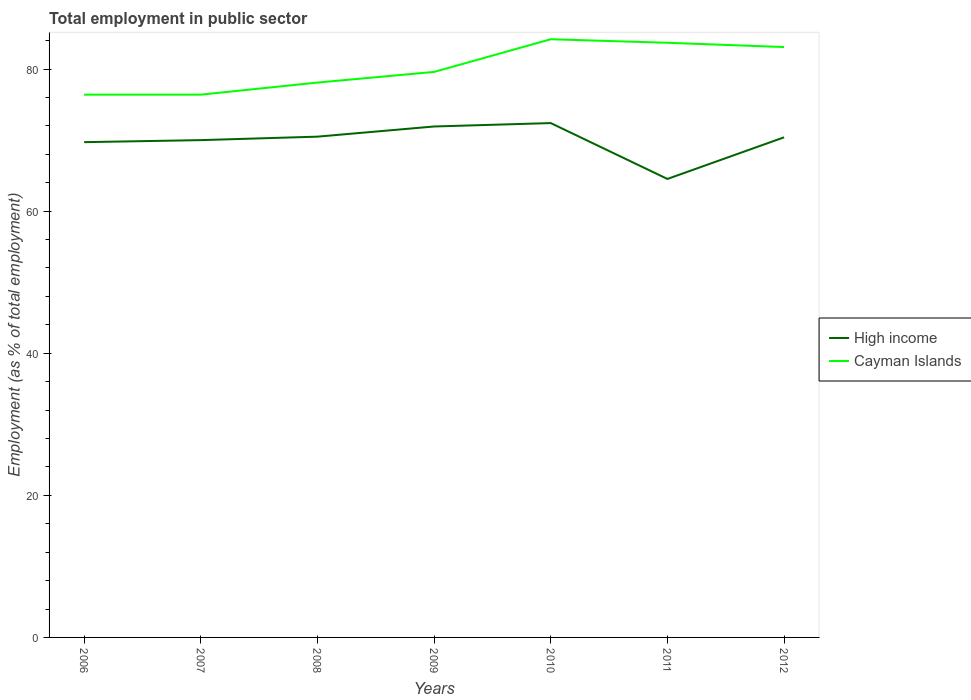Does the line corresponding to Cayman Islands intersect with the line corresponding to High income?
Offer a terse response. No. Across all years, what is the maximum employment in public sector in Cayman Islands?
Offer a terse response. 76.4. What is the total employment in public sector in High income in the graph?
Ensure brevity in your answer.  -0.4. What is the difference between the highest and the second highest employment in public sector in High income?
Provide a short and direct response. 7.86. What is the difference between the highest and the lowest employment in public sector in High income?
Your answer should be compact. 5. Is the employment in public sector in Cayman Islands strictly greater than the employment in public sector in High income over the years?
Ensure brevity in your answer.  No. How many lines are there?
Keep it short and to the point. 2. How many years are there in the graph?
Your answer should be compact. 7. Does the graph contain any zero values?
Offer a very short reply. No. Does the graph contain grids?
Your answer should be compact. No. Where does the legend appear in the graph?
Ensure brevity in your answer.  Center right. How many legend labels are there?
Your response must be concise. 2. What is the title of the graph?
Give a very brief answer. Total employment in public sector. Does "Liechtenstein" appear as one of the legend labels in the graph?
Your answer should be very brief. No. What is the label or title of the X-axis?
Provide a succinct answer. Years. What is the label or title of the Y-axis?
Your response must be concise. Employment (as % of total employment). What is the Employment (as % of total employment) of High income in 2006?
Your answer should be very brief. 69.71. What is the Employment (as % of total employment) in Cayman Islands in 2006?
Make the answer very short. 76.4. What is the Employment (as % of total employment) in High income in 2007?
Provide a short and direct response. 70. What is the Employment (as % of total employment) of Cayman Islands in 2007?
Your answer should be compact. 76.4. What is the Employment (as % of total employment) of High income in 2008?
Offer a terse response. 70.49. What is the Employment (as % of total employment) in Cayman Islands in 2008?
Offer a terse response. 78.1. What is the Employment (as % of total employment) of High income in 2009?
Ensure brevity in your answer.  71.92. What is the Employment (as % of total employment) of Cayman Islands in 2009?
Your response must be concise. 79.6. What is the Employment (as % of total employment) of High income in 2010?
Your answer should be compact. 72.4. What is the Employment (as % of total employment) of Cayman Islands in 2010?
Give a very brief answer. 84.2. What is the Employment (as % of total employment) of High income in 2011?
Offer a very short reply. 64.53. What is the Employment (as % of total employment) of Cayman Islands in 2011?
Keep it short and to the point. 83.7. What is the Employment (as % of total employment) in High income in 2012?
Give a very brief answer. 70.4. What is the Employment (as % of total employment) of Cayman Islands in 2012?
Your answer should be very brief. 83.1. Across all years, what is the maximum Employment (as % of total employment) of High income?
Make the answer very short. 72.4. Across all years, what is the maximum Employment (as % of total employment) of Cayman Islands?
Provide a succinct answer. 84.2. Across all years, what is the minimum Employment (as % of total employment) of High income?
Provide a succinct answer. 64.53. Across all years, what is the minimum Employment (as % of total employment) of Cayman Islands?
Keep it short and to the point. 76.4. What is the total Employment (as % of total employment) in High income in the graph?
Your answer should be compact. 489.45. What is the total Employment (as % of total employment) in Cayman Islands in the graph?
Your answer should be very brief. 561.5. What is the difference between the Employment (as % of total employment) of High income in 2006 and that in 2007?
Offer a terse response. -0.28. What is the difference between the Employment (as % of total employment) in High income in 2006 and that in 2008?
Ensure brevity in your answer.  -0.77. What is the difference between the Employment (as % of total employment) in Cayman Islands in 2006 and that in 2008?
Your answer should be compact. -1.7. What is the difference between the Employment (as % of total employment) of High income in 2006 and that in 2009?
Your answer should be very brief. -2.21. What is the difference between the Employment (as % of total employment) in High income in 2006 and that in 2010?
Offer a terse response. -2.68. What is the difference between the Employment (as % of total employment) in Cayman Islands in 2006 and that in 2010?
Your answer should be very brief. -7.8. What is the difference between the Employment (as % of total employment) of High income in 2006 and that in 2011?
Give a very brief answer. 5.18. What is the difference between the Employment (as % of total employment) in Cayman Islands in 2006 and that in 2011?
Offer a very short reply. -7.3. What is the difference between the Employment (as % of total employment) in High income in 2006 and that in 2012?
Provide a short and direct response. -0.68. What is the difference between the Employment (as % of total employment) of Cayman Islands in 2006 and that in 2012?
Offer a terse response. -6.7. What is the difference between the Employment (as % of total employment) in High income in 2007 and that in 2008?
Ensure brevity in your answer.  -0.49. What is the difference between the Employment (as % of total employment) of Cayman Islands in 2007 and that in 2008?
Provide a succinct answer. -1.7. What is the difference between the Employment (as % of total employment) of High income in 2007 and that in 2009?
Your response must be concise. -1.92. What is the difference between the Employment (as % of total employment) in High income in 2007 and that in 2010?
Offer a terse response. -2.4. What is the difference between the Employment (as % of total employment) of Cayman Islands in 2007 and that in 2010?
Keep it short and to the point. -7.8. What is the difference between the Employment (as % of total employment) of High income in 2007 and that in 2011?
Provide a short and direct response. 5.46. What is the difference between the Employment (as % of total employment) of High income in 2007 and that in 2012?
Your answer should be very brief. -0.4. What is the difference between the Employment (as % of total employment) in High income in 2008 and that in 2009?
Your answer should be compact. -1.43. What is the difference between the Employment (as % of total employment) in High income in 2008 and that in 2010?
Provide a succinct answer. -1.91. What is the difference between the Employment (as % of total employment) in Cayman Islands in 2008 and that in 2010?
Your answer should be compact. -6.1. What is the difference between the Employment (as % of total employment) in High income in 2008 and that in 2011?
Offer a very short reply. 5.95. What is the difference between the Employment (as % of total employment) in Cayman Islands in 2008 and that in 2011?
Your answer should be very brief. -5.6. What is the difference between the Employment (as % of total employment) in High income in 2008 and that in 2012?
Your response must be concise. 0.09. What is the difference between the Employment (as % of total employment) in High income in 2009 and that in 2010?
Your answer should be very brief. -0.48. What is the difference between the Employment (as % of total employment) of Cayman Islands in 2009 and that in 2010?
Offer a terse response. -4.6. What is the difference between the Employment (as % of total employment) of High income in 2009 and that in 2011?
Your answer should be very brief. 7.38. What is the difference between the Employment (as % of total employment) of Cayman Islands in 2009 and that in 2011?
Keep it short and to the point. -4.1. What is the difference between the Employment (as % of total employment) in High income in 2009 and that in 2012?
Provide a short and direct response. 1.52. What is the difference between the Employment (as % of total employment) in High income in 2010 and that in 2011?
Offer a very short reply. 7.86. What is the difference between the Employment (as % of total employment) of High income in 2010 and that in 2012?
Offer a very short reply. 2. What is the difference between the Employment (as % of total employment) in Cayman Islands in 2010 and that in 2012?
Your answer should be very brief. 1.1. What is the difference between the Employment (as % of total employment) in High income in 2011 and that in 2012?
Offer a terse response. -5.86. What is the difference between the Employment (as % of total employment) in High income in 2006 and the Employment (as % of total employment) in Cayman Islands in 2007?
Provide a succinct answer. -6.69. What is the difference between the Employment (as % of total employment) in High income in 2006 and the Employment (as % of total employment) in Cayman Islands in 2008?
Your answer should be compact. -8.39. What is the difference between the Employment (as % of total employment) in High income in 2006 and the Employment (as % of total employment) in Cayman Islands in 2009?
Ensure brevity in your answer.  -9.89. What is the difference between the Employment (as % of total employment) in High income in 2006 and the Employment (as % of total employment) in Cayman Islands in 2010?
Offer a terse response. -14.49. What is the difference between the Employment (as % of total employment) of High income in 2006 and the Employment (as % of total employment) of Cayman Islands in 2011?
Make the answer very short. -13.99. What is the difference between the Employment (as % of total employment) in High income in 2006 and the Employment (as % of total employment) in Cayman Islands in 2012?
Your answer should be very brief. -13.39. What is the difference between the Employment (as % of total employment) in High income in 2007 and the Employment (as % of total employment) in Cayman Islands in 2008?
Make the answer very short. -8.1. What is the difference between the Employment (as % of total employment) in High income in 2007 and the Employment (as % of total employment) in Cayman Islands in 2009?
Make the answer very short. -9.6. What is the difference between the Employment (as % of total employment) in High income in 2007 and the Employment (as % of total employment) in Cayman Islands in 2010?
Your answer should be very brief. -14.2. What is the difference between the Employment (as % of total employment) in High income in 2007 and the Employment (as % of total employment) in Cayman Islands in 2011?
Keep it short and to the point. -13.7. What is the difference between the Employment (as % of total employment) in High income in 2007 and the Employment (as % of total employment) in Cayman Islands in 2012?
Make the answer very short. -13.1. What is the difference between the Employment (as % of total employment) of High income in 2008 and the Employment (as % of total employment) of Cayman Islands in 2009?
Keep it short and to the point. -9.11. What is the difference between the Employment (as % of total employment) of High income in 2008 and the Employment (as % of total employment) of Cayman Islands in 2010?
Make the answer very short. -13.71. What is the difference between the Employment (as % of total employment) of High income in 2008 and the Employment (as % of total employment) of Cayman Islands in 2011?
Keep it short and to the point. -13.21. What is the difference between the Employment (as % of total employment) in High income in 2008 and the Employment (as % of total employment) in Cayman Islands in 2012?
Offer a terse response. -12.61. What is the difference between the Employment (as % of total employment) of High income in 2009 and the Employment (as % of total employment) of Cayman Islands in 2010?
Give a very brief answer. -12.28. What is the difference between the Employment (as % of total employment) of High income in 2009 and the Employment (as % of total employment) of Cayman Islands in 2011?
Offer a very short reply. -11.78. What is the difference between the Employment (as % of total employment) of High income in 2009 and the Employment (as % of total employment) of Cayman Islands in 2012?
Your answer should be compact. -11.18. What is the difference between the Employment (as % of total employment) in High income in 2010 and the Employment (as % of total employment) in Cayman Islands in 2011?
Your response must be concise. -11.3. What is the difference between the Employment (as % of total employment) in High income in 2010 and the Employment (as % of total employment) in Cayman Islands in 2012?
Your answer should be very brief. -10.7. What is the difference between the Employment (as % of total employment) in High income in 2011 and the Employment (as % of total employment) in Cayman Islands in 2012?
Provide a short and direct response. -18.57. What is the average Employment (as % of total employment) of High income per year?
Your answer should be compact. 69.92. What is the average Employment (as % of total employment) in Cayman Islands per year?
Provide a succinct answer. 80.21. In the year 2006, what is the difference between the Employment (as % of total employment) of High income and Employment (as % of total employment) of Cayman Islands?
Offer a terse response. -6.69. In the year 2007, what is the difference between the Employment (as % of total employment) in High income and Employment (as % of total employment) in Cayman Islands?
Offer a terse response. -6.4. In the year 2008, what is the difference between the Employment (as % of total employment) in High income and Employment (as % of total employment) in Cayman Islands?
Provide a short and direct response. -7.61. In the year 2009, what is the difference between the Employment (as % of total employment) of High income and Employment (as % of total employment) of Cayman Islands?
Keep it short and to the point. -7.68. In the year 2010, what is the difference between the Employment (as % of total employment) of High income and Employment (as % of total employment) of Cayman Islands?
Keep it short and to the point. -11.8. In the year 2011, what is the difference between the Employment (as % of total employment) of High income and Employment (as % of total employment) of Cayman Islands?
Your response must be concise. -19.17. In the year 2012, what is the difference between the Employment (as % of total employment) of High income and Employment (as % of total employment) of Cayman Islands?
Your answer should be very brief. -12.71. What is the ratio of the Employment (as % of total employment) of Cayman Islands in 2006 to that in 2008?
Give a very brief answer. 0.98. What is the ratio of the Employment (as % of total employment) of High income in 2006 to that in 2009?
Your answer should be compact. 0.97. What is the ratio of the Employment (as % of total employment) of Cayman Islands in 2006 to that in 2009?
Make the answer very short. 0.96. What is the ratio of the Employment (as % of total employment) of High income in 2006 to that in 2010?
Your answer should be very brief. 0.96. What is the ratio of the Employment (as % of total employment) of Cayman Islands in 2006 to that in 2010?
Your response must be concise. 0.91. What is the ratio of the Employment (as % of total employment) in High income in 2006 to that in 2011?
Your answer should be compact. 1.08. What is the ratio of the Employment (as % of total employment) of Cayman Islands in 2006 to that in 2011?
Offer a terse response. 0.91. What is the ratio of the Employment (as % of total employment) in High income in 2006 to that in 2012?
Provide a succinct answer. 0.99. What is the ratio of the Employment (as % of total employment) of Cayman Islands in 2006 to that in 2012?
Ensure brevity in your answer.  0.92. What is the ratio of the Employment (as % of total employment) in High income in 2007 to that in 2008?
Your answer should be very brief. 0.99. What is the ratio of the Employment (as % of total employment) of Cayman Islands in 2007 to that in 2008?
Your answer should be very brief. 0.98. What is the ratio of the Employment (as % of total employment) of High income in 2007 to that in 2009?
Give a very brief answer. 0.97. What is the ratio of the Employment (as % of total employment) in Cayman Islands in 2007 to that in 2009?
Your response must be concise. 0.96. What is the ratio of the Employment (as % of total employment) in High income in 2007 to that in 2010?
Your answer should be compact. 0.97. What is the ratio of the Employment (as % of total employment) in Cayman Islands in 2007 to that in 2010?
Make the answer very short. 0.91. What is the ratio of the Employment (as % of total employment) in High income in 2007 to that in 2011?
Give a very brief answer. 1.08. What is the ratio of the Employment (as % of total employment) of Cayman Islands in 2007 to that in 2011?
Your answer should be compact. 0.91. What is the ratio of the Employment (as % of total employment) in Cayman Islands in 2007 to that in 2012?
Provide a succinct answer. 0.92. What is the ratio of the Employment (as % of total employment) in High income in 2008 to that in 2009?
Ensure brevity in your answer.  0.98. What is the ratio of the Employment (as % of total employment) of Cayman Islands in 2008 to that in 2009?
Your response must be concise. 0.98. What is the ratio of the Employment (as % of total employment) in High income in 2008 to that in 2010?
Your response must be concise. 0.97. What is the ratio of the Employment (as % of total employment) in Cayman Islands in 2008 to that in 2010?
Give a very brief answer. 0.93. What is the ratio of the Employment (as % of total employment) of High income in 2008 to that in 2011?
Give a very brief answer. 1.09. What is the ratio of the Employment (as % of total employment) of Cayman Islands in 2008 to that in 2011?
Give a very brief answer. 0.93. What is the ratio of the Employment (as % of total employment) in High income in 2008 to that in 2012?
Give a very brief answer. 1. What is the ratio of the Employment (as % of total employment) in Cayman Islands in 2008 to that in 2012?
Provide a succinct answer. 0.94. What is the ratio of the Employment (as % of total employment) in Cayman Islands in 2009 to that in 2010?
Your answer should be compact. 0.95. What is the ratio of the Employment (as % of total employment) of High income in 2009 to that in 2011?
Ensure brevity in your answer.  1.11. What is the ratio of the Employment (as % of total employment) in Cayman Islands in 2009 to that in 2011?
Your answer should be very brief. 0.95. What is the ratio of the Employment (as % of total employment) in High income in 2009 to that in 2012?
Keep it short and to the point. 1.02. What is the ratio of the Employment (as % of total employment) of Cayman Islands in 2009 to that in 2012?
Offer a terse response. 0.96. What is the ratio of the Employment (as % of total employment) in High income in 2010 to that in 2011?
Ensure brevity in your answer.  1.12. What is the ratio of the Employment (as % of total employment) of High income in 2010 to that in 2012?
Offer a very short reply. 1.03. What is the ratio of the Employment (as % of total employment) of Cayman Islands in 2010 to that in 2012?
Provide a short and direct response. 1.01. What is the difference between the highest and the second highest Employment (as % of total employment) in High income?
Provide a short and direct response. 0.48. What is the difference between the highest and the second highest Employment (as % of total employment) of Cayman Islands?
Provide a short and direct response. 0.5. What is the difference between the highest and the lowest Employment (as % of total employment) of High income?
Your answer should be very brief. 7.86. What is the difference between the highest and the lowest Employment (as % of total employment) in Cayman Islands?
Your answer should be compact. 7.8. 